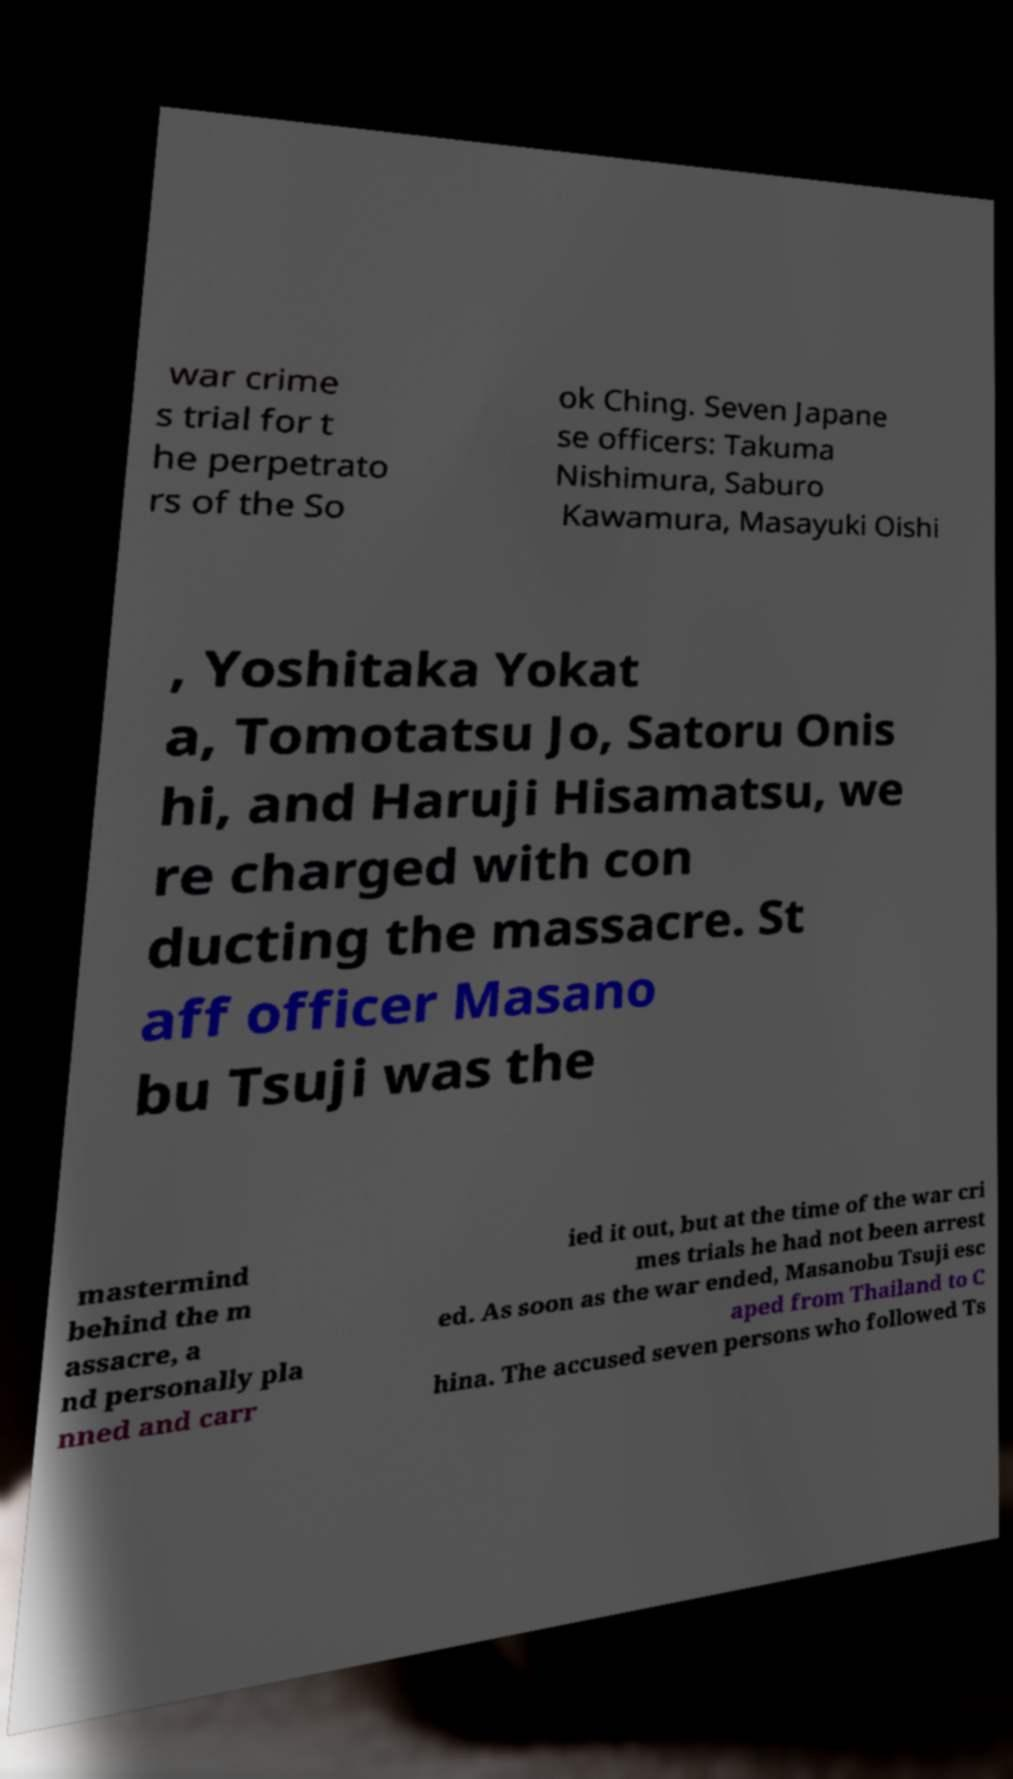Can you accurately transcribe the text from the provided image for me? war crime s trial for t he perpetrato rs of the So ok Ching. Seven Japane se officers: Takuma Nishimura, Saburo Kawamura, Masayuki Oishi , Yoshitaka Yokat a, Tomotatsu Jo, Satoru Onis hi, and Haruji Hisamatsu, we re charged with con ducting the massacre. St aff officer Masano bu Tsuji was the mastermind behind the m assacre, a nd personally pla nned and carr ied it out, but at the time of the war cri mes trials he had not been arrest ed. As soon as the war ended, Masanobu Tsuji esc aped from Thailand to C hina. The accused seven persons who followed Ts 